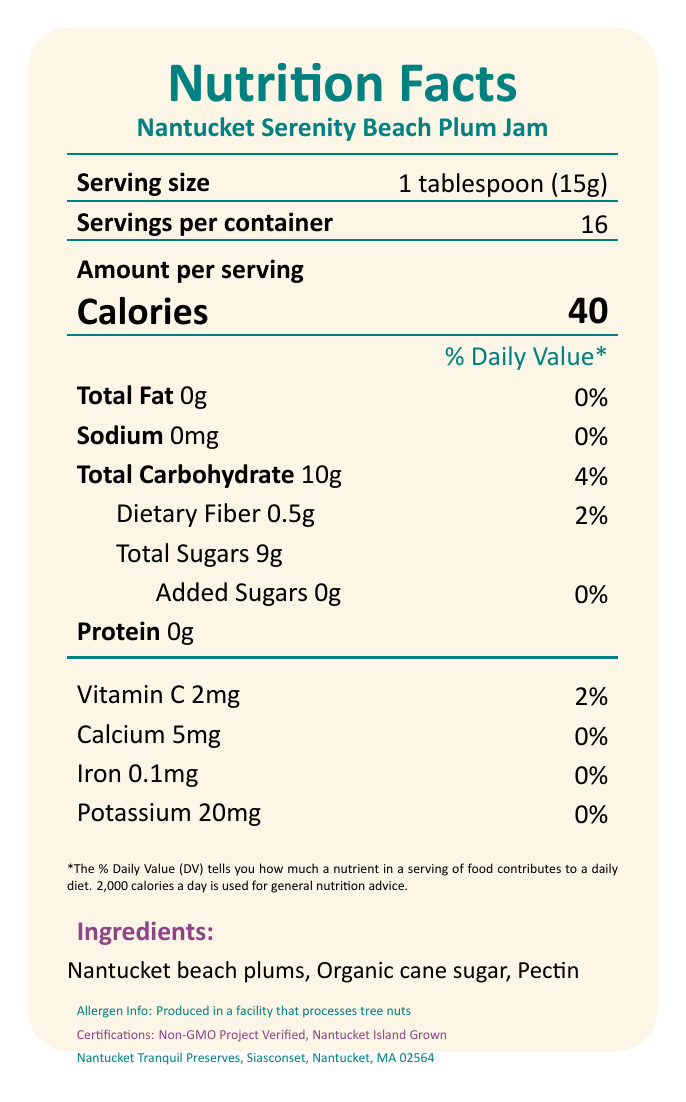what is the serving size? The label clearly mentions "Serving size: 1 tablespoon (15g)" near the top.
Answer: 1 tablespoon (15g) how many servings are there per container? According to the document, it states "Servings per container: 16."
Answer: 16 servings how many calories are in one serving? The label shows "Calories: 40" under the "Amount per serving" section.
Answer: 40 calories what is the total fat content per serving? The document states "Total Fat: 0g" in the nutrition facts section.
Answer: 0g how much dietary fiber does one serving of the jam provide? The nutrition facts section lists "Dietary Fiber: 0.5g."
Answer: 0.5g what type of packaging is used for this product? It is mentioned in the additional information section: "Eco-friendly glass jar packaging."
Answer: Eco-friendly glass jar what is the daily value percentage of sodium per serving? The document states "Sodium: 0mg" and "0%" for the daily value percentage.
Answer: 0% which ingredient is not listed in the ingredient list? A. Organic cane sugar B. Corn syrup C. Pectin D. Beach plums The correct answer is "Corn syrup". The listed ingredients are Nantucket beach plums, Organic cane sugar, and Pectin.
Answer: B which certification does the jam have? A. Organic Certified B. Non-GMO Project Verified C. Gluten-Free Certified D. Fair Trade Certified The correct option is "Non-GMO Project Verified" as per the certifications listed in the document.
Answer: B is this product produced in a facility that processes tree nuts? The allergen information clearly states, "Produced in a facility that processes tree nuts."
Answer: Yes summarize the main nutritional insights of the Nantucket Serenity Beach Plum Jam. The document primarily highlights the low additive content, nutritional values per serving, and certifications emphasizing natural and eco-friendly attributes.
Answer: The Nantucket Serenity Beach Plum Jam is a naturally sweet jam with low additives. Each 1-tablespoon serving contains 40 calories, 0g of fat, 10g of carbohydrates, 9g of total sugars, and 0g of added sugars. It also provides small amounts of dietary fiber, Vitamin C, calcium, iron, and potassium. The product is Non-GMO Project Verified and uses eco-friendly packaging. how much protein is in each serving? The document lists "Protein: 0g" in the nutrition facts section.
Answer: 0g does the jam contain any added sugars? The document shows "Added Sugars 0g" and the daily value percentage is listed as 0%.
Answer: No how is the jam prepared? In the additional information section, it specifies "Small-batch crafted for optimal flavor."
Answer: Small-batch crafted for optimal flavor does the label indicate if the jam is gluten-free? The document does not mention anything about being gluten-free.
Answer: Not enough information what is the company location for Nantucket Tranquil Preserves? The company info located at the bottom states "Siasconset, Nantucket, MA 02564."
Answer: Siasconset, Nantucket, MA 02564 